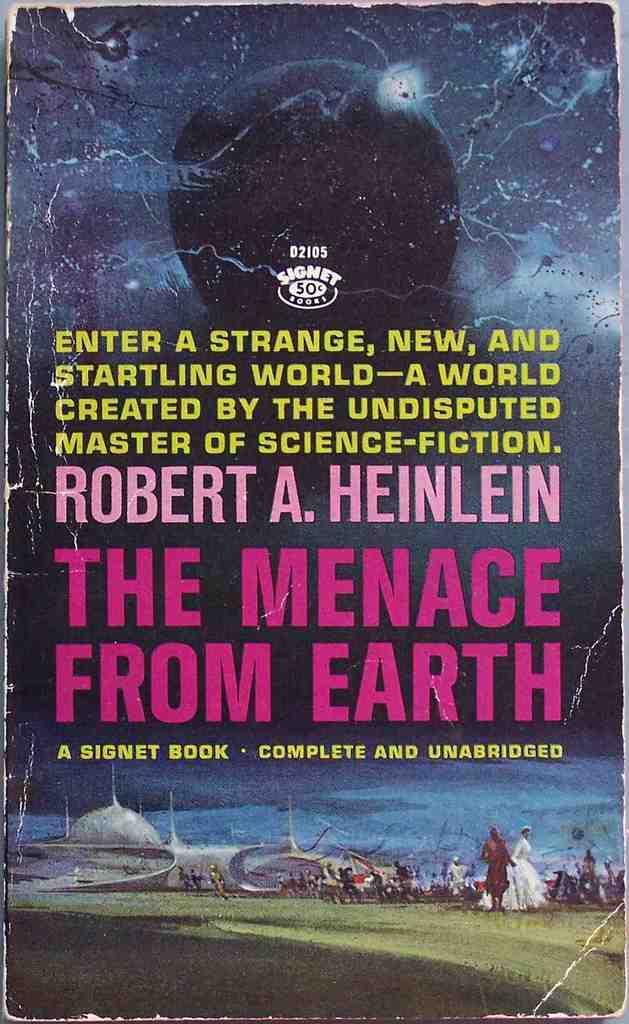<image>
Describe the image concisely. A faded book cover says The Menace From Earth. 